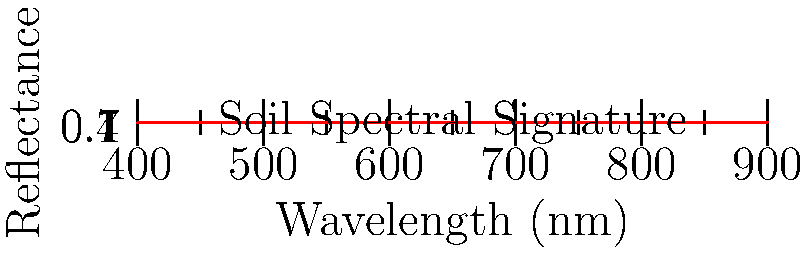Based on the spectral signature shown in the graph, which nutrient is most likely to be abundant in the soil sample? To answer this question, we need to analyze the spectral signature of the soil sample:

1. The graph shows reflectance values across different wavelengths (400-900 nm).
2. The reflectance increases significantly in the near-infrared region (700-900 nm).
3. This pattern is characteristic of healthy vegetation and soils rich in organic matter.
4. Organic matter is closely associated with nitrogen content in soils.
5. High reflectance in the near-infrared region often indicates higher nitrogen levels.
6. Other nutrients like phosphorus and potassium don't typically cause such a distinct increase in near-infrared reflectance.
7. As a biology teacher familiar with farm work, you would recognize that nitrogen is a crucial nutrient for plant growth and soil health.

Therefore, based on the spectral signature, nitrogen is the nutrient most likely to be abundant in this soil sample.
Answer: Nitrogen 